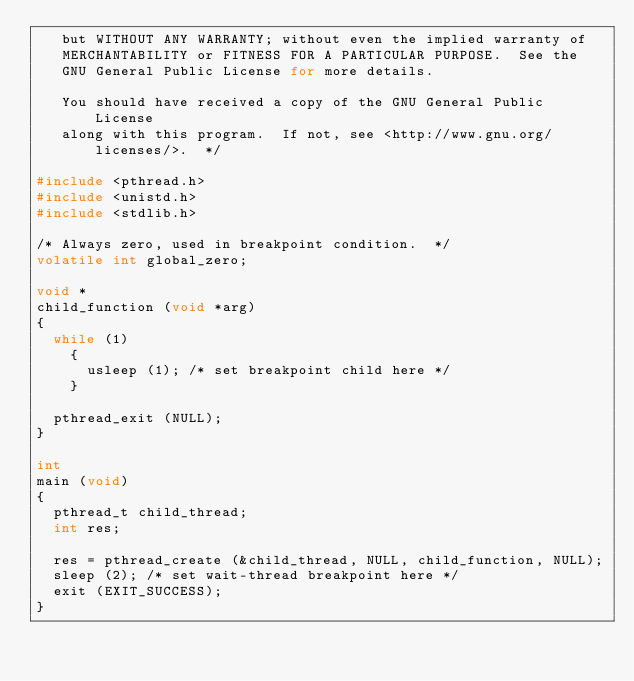Convert code to text. <code><loc_0><loc_0><loc_500><loc_500><_C_>   but WITHOUT ANY WARRANTY; without even the implied warranty of
   MERCHANTABILITY or FITNESS FOR A PARTICULAR PURPOSE.  See the
   GNU General Public License for more details.

   You should have received a copy of the GNU General Public License
   along with this program.  If not, see <http://www.gnu.org/licenses/>.  */

#include <pthread.h>
#include <unistd.h>
#include <stdlib.h>

/* Always zero, used in breakpoint condition.  */
volatile int global_zero;

void *
child_function (void *arg)
{
  while (1)
    {
      usleep (1); /* set breakpoint child here */
    }

  pthread_exit (NULL);
}

int
main (void)
{
  pthread_t child_thread;
  int res;

  res = pthread_create (&child_thread, NULL, child_function, NULL);
  sleep (2); /* set wait-thread breakpoint here */
  exit (EXIT_SUCCESS);
}
</code> 